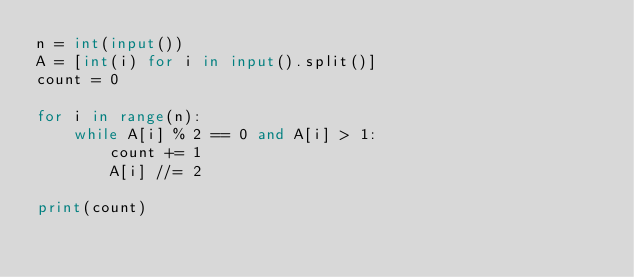Convert code to text. <code><loc_0><loc_0><loc_500><loc_500><_Python_>n = int(input())
A = [int(i) for i in input().split()]
count = 0

for i in range(n):
    while A[i] % 2 == 0 and A[i] > 1:
        count += 1
        A[i] //= 2
            
print(count)</code> 